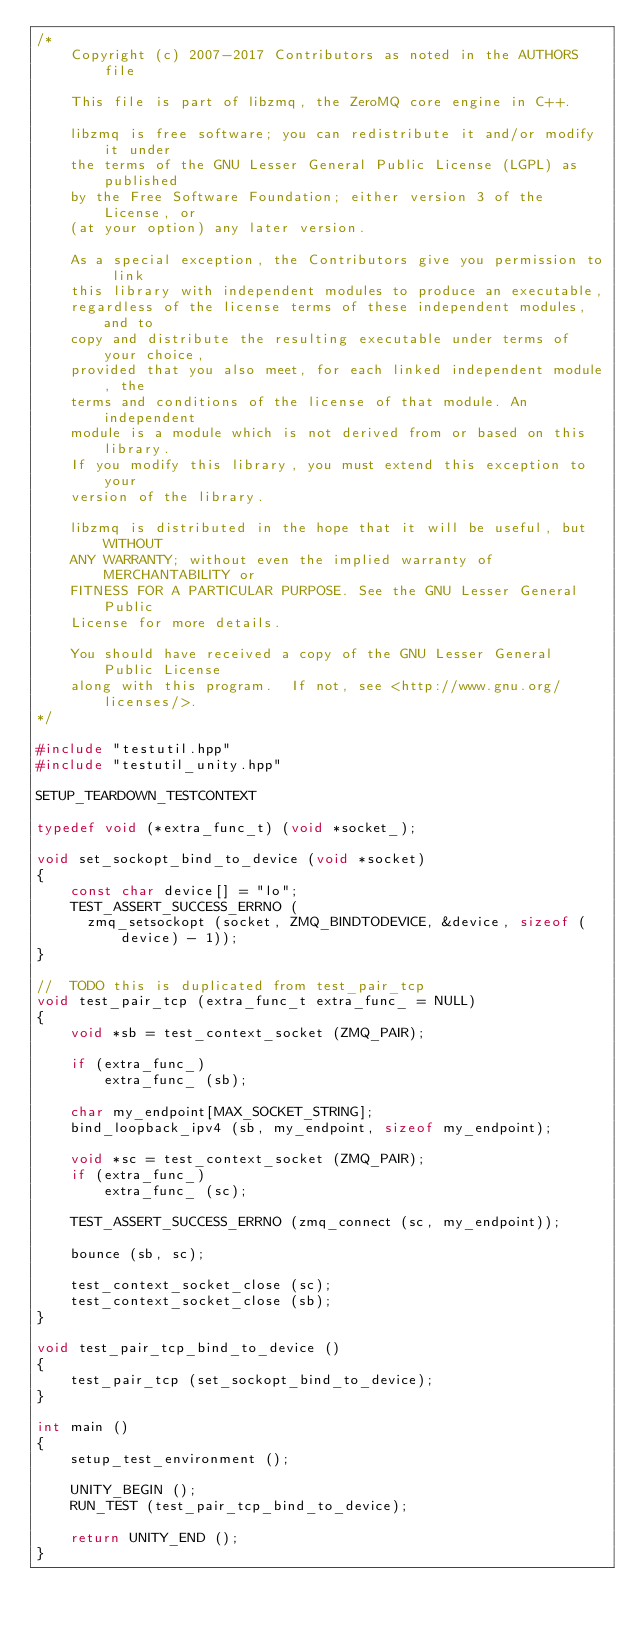<code> <loc_0><loc_0><loc_500><loc_500><_C++_>/*
    Copyright (c) 2007-2017 Contributors as noted in the AUTHORS file

    This file is part of libzmq, the ZeroMQ core engine in C++.

    libzmq is free software; you can redistribute it and/or modify it under
    the terms of the GNU Lesser General Public License (LGPL) as published
    by the Free Software Foundation; either version 3 of the License, or
    (at your option) any later version.

    As a special exception, the Contributors give you permission to link
    this library with independent modules to produce an executable,
    regardless of the license terms of these independent modules, and to
    copy and distribute the resulting executable under terms of your choice,
    provided that you also meet, for each linked independent module, the
    terms and conditions of the license of that module. An independent
    module is a module which is not derived from or based on this library.
    If you modify this library, you must extend this exception to your
    version of the library.

    libzmq is distributed in the hope that it will be useful, but WITHOUT
    ANY WARRANTY; without even the implied warranty of MERCHANTABILITY or
    FITNESS FOR A PARTICULAR PURPOSE. See the GNU Lesser General Public
    License for more details.

    You should have received a copy of the GNU Lesser General Public License
    along with this program.  If not, see <http://www.gnu.org/licenses/>.
*/

#include "testutil.hpp"
#include "testutil_unity.hpp"

SETUP_TEARDOWN_TESTCONTEXT

typedef void (*extra_func_t) (void *socket_);

void set_sockopt_bind_to_device (void *socket)
{
    const char device[] = "lo";
    TEST_ASSERT_SUCCESS_ERRNO (
      zmq_setsockopt (socket, ZMQ_BINDTODEVICE, &device, sizeof (device) - 1));
}

//  TODO this is duplicated from test_pair_tcp
void test_pair_tcp (extra_func_t extra_func_ = NULL)
{
    void *sb = test_context_socket (ZMQ_PAIR);

    if (extra_func_)
        extra_func_ (sb);

    char my_endpoint[MAX_SOCKET_STRING];
    bind_loopback_ipv4 (sb, my_endpoint, sizeof my_endpoint);

    void *sc = test_context_socket (ZMQ_PAIR);
    if (extra_func_)
        extra_func_ (sc);

    TEST_ASSERT_SUCCESS_ERRNO (zmq_connect (sc, my_endpoint));

    bounce (sb, sc);

    test_context_socket_close (sc);
    test_context_socket_close (sb);
}

void test_pair_tcp_bind_to_device ()
{
    test_pair_tcp (set_sockopt_bind_to_device);
}

int main ()
{
    setup_test_environment ();

    UNITY_BEGIN ();
    RUN_TEST (test_pair_tcp_bind_to_device);

    return UNITY_END ();
}
</code> 